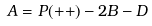Convert formula to latex. <formula><loc_0><loc_0><loc_500><loc_500>A = P ( + + ) - 2 B - D</formula> 